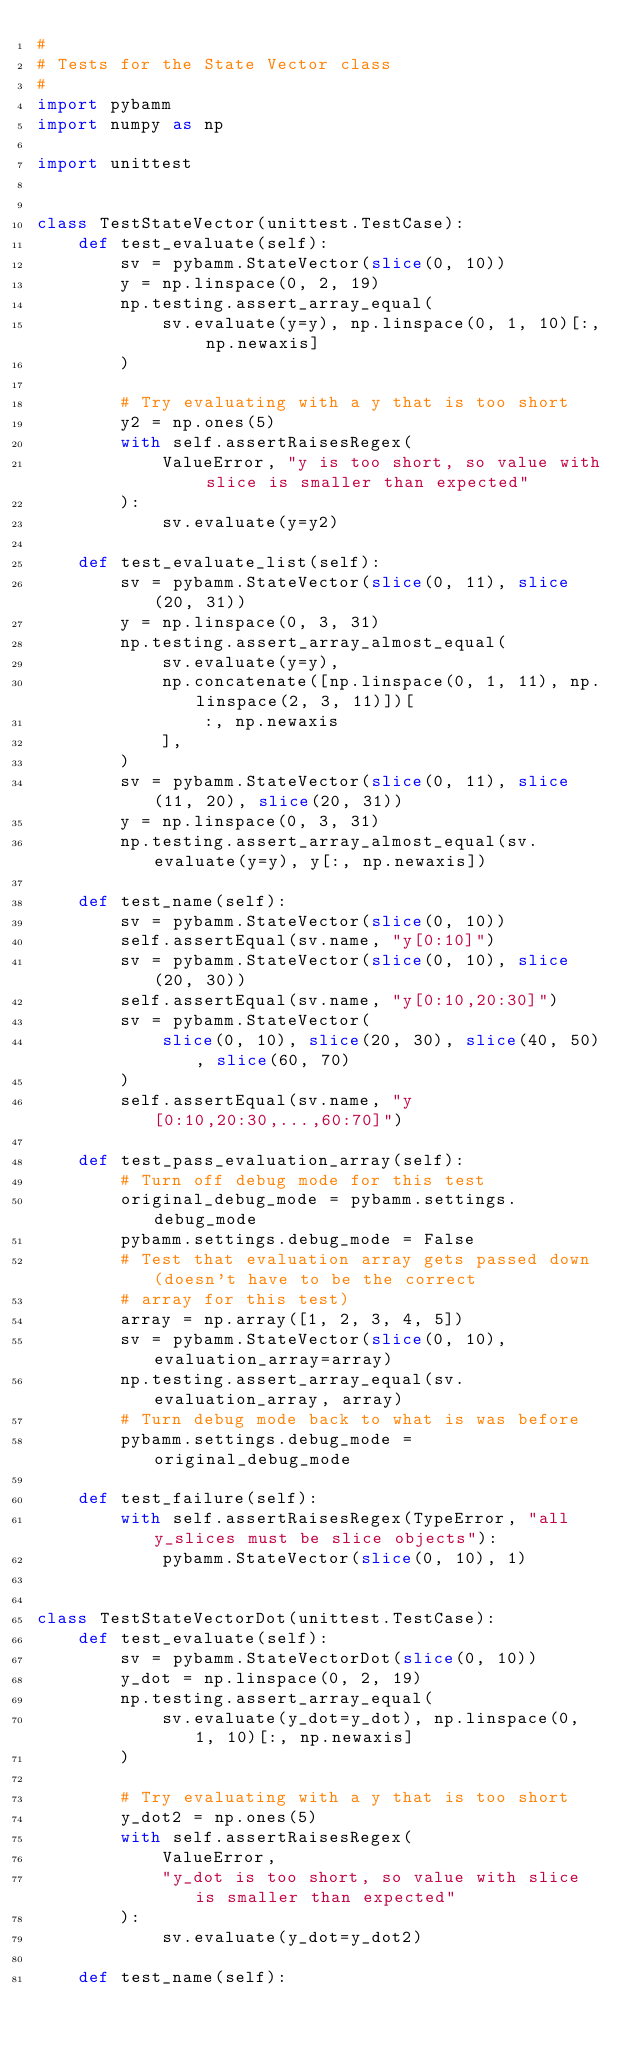<code> <loc_0><loc_0><loc_500><loc_500><_Python_>#
# Tests for the State Vector class
#
import pybamm
import numpy as np

import unittest


class TestStateVector(unittest.TestCase):
    def test_evaluate(self):
        sv = pybamm.StateVector(slice(0, 10))
        y = np.linspace(0, 2, 19)
        np.testing.assert_array_equal(
            sv.evaluate(y=y), np.linspace(0, 1, 10)[:, np.newaxis]
        )

        # Try evaluating with a y that is too short
        y2 = np.ones(5)
        with self.assertRaisesRegex(
            ValueError, "y is too short, so value with slice is smaller than expected"
        ):
            sv.evaluate(y=y2)

    def test_evaluate_list(self):
        sv = pybamm.StateVector(slice(0, 11), slice(20, 31))
        y = np.linspace(0, 3, 31)
        np.testing.assert_array_almost_equal(
            sv.evaluate(y=y),
            np.concatenate([np.linspace(0, 1, 11), np.linspace(2, 3, 11)])[
                :, np.newaxis
            ],
        )
        sv = pybamm.StateVector(slice(0, 11), slice(11, 20), slice(20, 31))
        y = np.linspace(0, 3, 31)
        np.testing.assert_array_almost_equal(sv.evaluate(y=y), y[:, np.newaxis])

    def test_name(self):
        sv = pybamm.StateVector(slice(0, 10))
        self.assertEqual(sv.name, "y[0:10]")
        sv = pybamm.StateVector(slice(0, 10), slice(20, 30))
        self.assertEqual(sv.name, "y[0:10,20:30]")
        sv = pybamm.StateVector(
            slice(0, 10), slice(20, 30), slice(40, 50), slice(60, 70)
        )
        self.assertEqual(sv.name, "y[0:10,20:30,...,60:70]")

    def test_pass_evaluation_array(self):
        # Turn off debug mode for this test
        original_debug_mode = pybamm.settings.debug_mode
        pybamm.settings.debug_mode = False
        # Test that evaluation array gets passed down (doesn't have to be the correct
        # array for this test)
        array = np.array([1, 2, 3, 4, 5])
        sv = pybamm.StateVector(slice(0, 10), evaluation_array=array)
        np.testing.assert_array_equal(sv.evaluation_array, array)
        # Turn debug mode back to what is was before
        pybamm.settings.debug_mode = original_debug_mode

    def test_failure(self):
        with self.assertRaisesRegex(TypeError, "all y_slices must be slice objects"):
            pybamm.StateVector(slice(0, 10), 1)


class TestStateVectorDot(unittest.TestCase):
    def test_evaluate(self):
        sv = pybamm.StateVectorDot(slice(0, 10))
        y_dot = np.linspace(0, 2, 19)
        np.testing.assert_array_equal(
            sv.evaluate(y_dot=y_dot), np.linspace(0, 1, 10)[:, np.newaxis]
        )

        # Try evaluating with a y that is too short
        y_dot2 = np.ones(5)
        with self.assertRaisesRegex(
            ValueError,
            "y_dot is too short, so value with slice is smaller than expected"
        ):
            sv.evaluate(y_dot=y_dot2)

    def test_name(self):</code> 